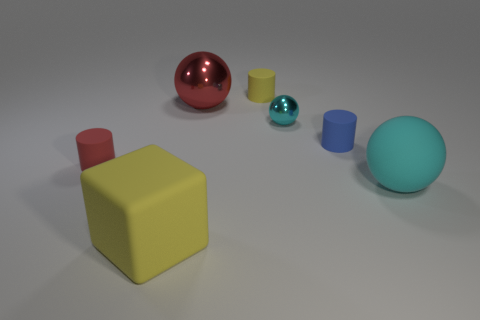Subtract all yellow rubber cylinders. How many cylinders are left? 2 Subtract all purple cylinders. How many cyan spheres are left? 2 Subtract 1 cylinders. How many cylinders are left? 2 Add 1 red things. How many objects exist? 8 Subtract all balls. How many objects are left? 4 Subtract all green spheres. Subtract all green cylinders. How many spheres are left? 3 Subtract all red cylinders. Subtract all small cyan metallic things. How many objects are left? 5 Add 5 red metallic spheres. How many red metallic spheres are left? 6 Add 6 big cyan matte things. How many big cyan matte things exist? 7 Subtract 0 green cylinders. How many objects are left? 7 